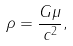<formula> <loc_0><loc_0><loc_500><loc_500>\rho = \frac { G \mu } { c ^ { 2 } } ,</formula> 